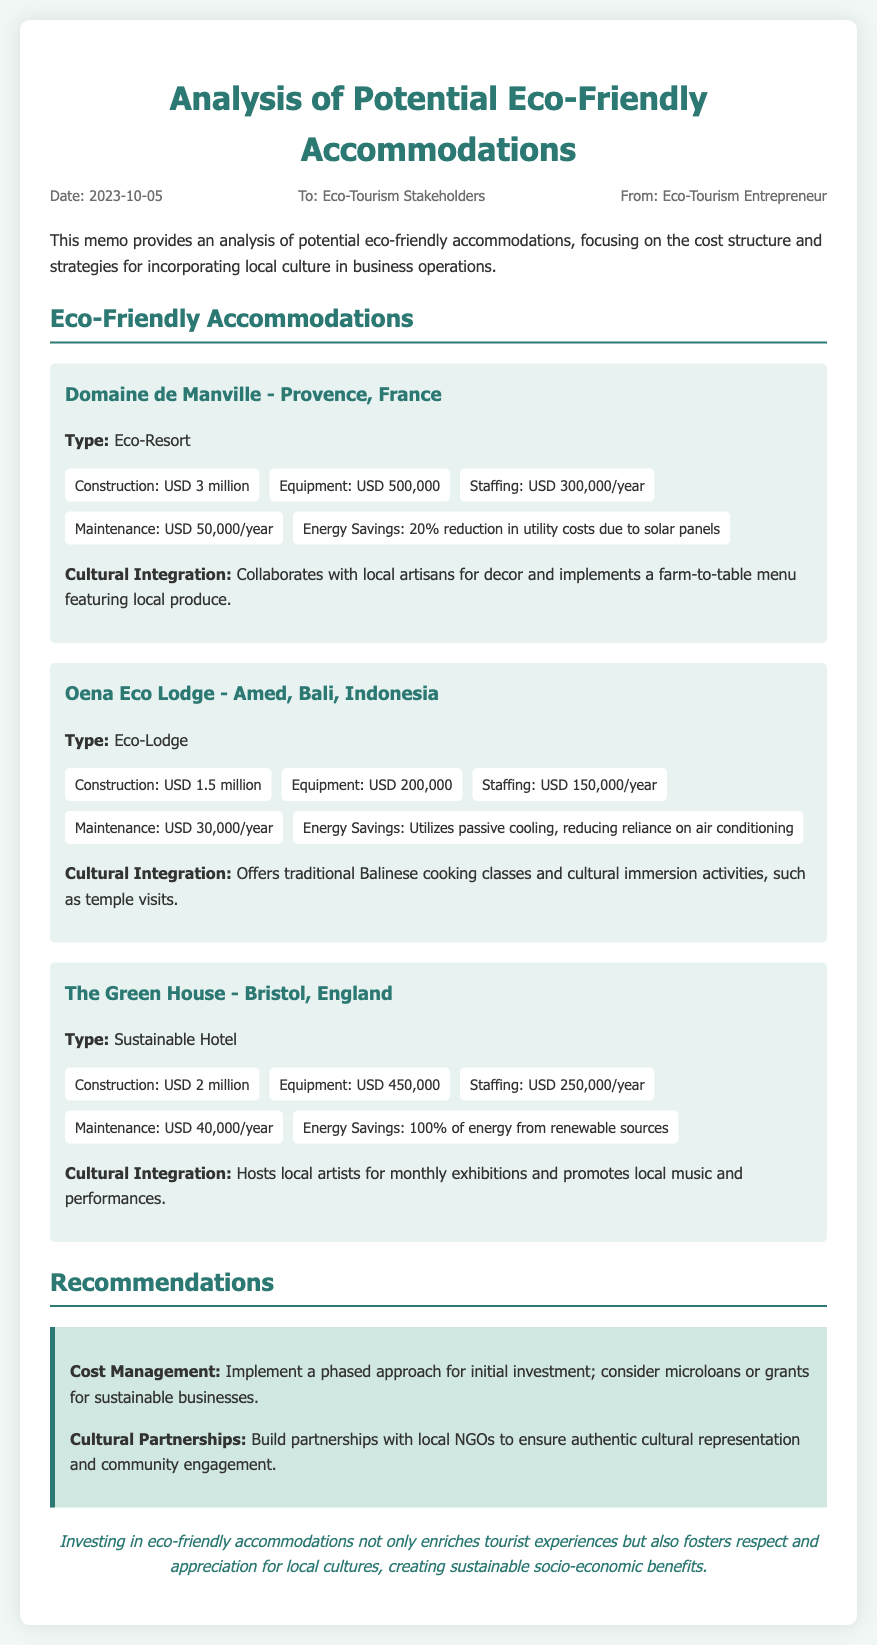What is the date of the memo? The date is clearly mentioned in the meta section of the document.
Answer: 2023-10-05 What is the construction cost of Domaine de Manville? The construction cost is specified in the cost breakdown of that accommodation.
Answer: USD 3 million How much is the annual staffing cost for Oena Eco Lodge? The annual staffing cost is provided in the cost breakdown of that accommodation.
Answer: USD 150,000/year What cultural activity does The Green House promote? The document lists specific cultural integration strategies for each accommodation.
Answer: Local music and performances Which accommodation has a 100% renewable energy source? The energy savings section reveals which accommodation utilizes this source.
Answer: The Green House What recommendation is made for cost management? The recommendations section outlines specific strategies for managing costs effectively.
Answer: Implement a phased approach for initial investment What unique feature does Oena Eco Lodge include for guests? This information is found under the cultural integration section for that accommodation.
Answer: Traditional Balinese cooking classes How much is the maintenance cost for Domaine de Manville? The maintenance cost is indicated in the cost breakdown of that accommodation.
Answer: USD 50,000/year What is the overall conclusion of the memo? The conclusion summarizes the impact of eco-friendly accommodations on local cultures.
Answer: Investing in eco-friendly accommodations not only enriches tourist experiences but also fosters respect and appreciation for local cultures, creating sustainable socio-economic benefits 